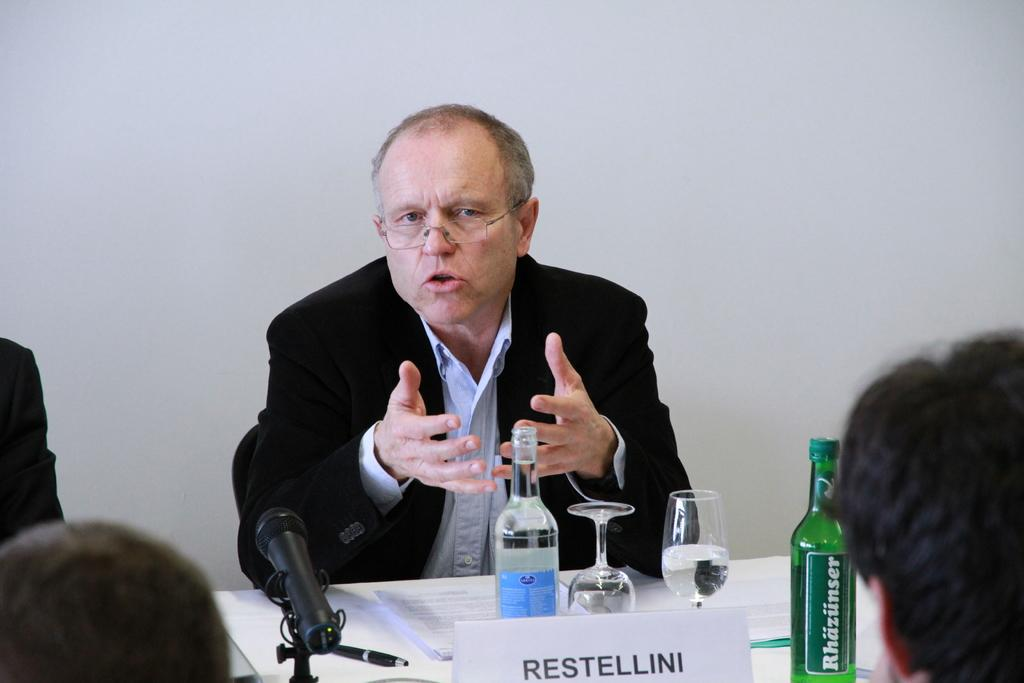What is the man in the image doing? The man is sitting and talking in the image. What objects are related to drinking in the image? There are two glasses and two bottles in the image. What device is present for amplifying sound? There is a microphone in the image. What surface is used for writing or displaying information? There is a board in the image. What items are on the table in the image? There are papers on a table in the image. What can be seen in the background of the image? There is a wall in the background of the image. What type of brake is being discussed by the man in the image? There is no mention of a brake or any discussion about it in the image. 